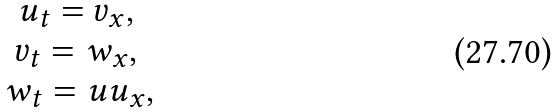Convert formula to latex. <formula><loc_0><loc_0><loc_500><loc_500>\begin{matrix} u _ { t } = v _ { x } , \, \\ v _ { t } = w _ { x } , \, \\ w _ { t } = u u _ { x } , \end{matrix}</formula> 